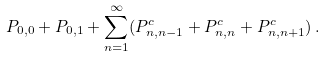<formula> <loc_0><loc_0><loc_500><loc_500>P _ { 0 , 0 } + P _ { 0 , 1 } + \sum _ { n = 1 } ^ { \infty } ( P _ { n , n - 1 } ^ { c } + P _ { n , n } ^ { c } + P _ { n , n + 1 } ^ { c } ) \, .</formula> 